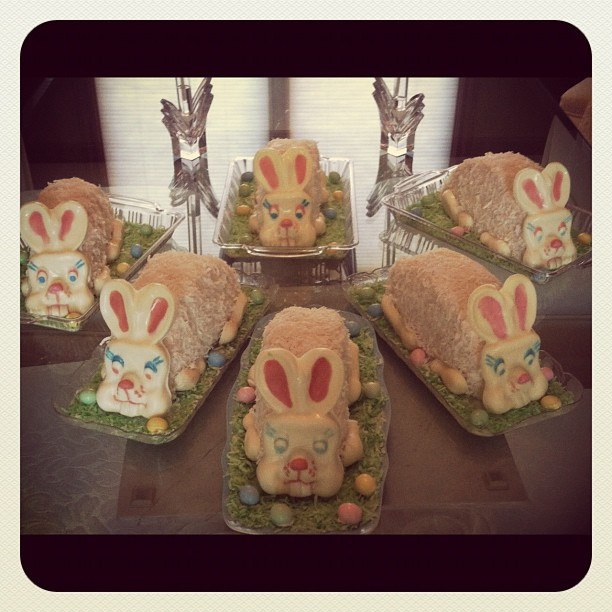Describe the objects in this image and their specific colors. I can see cake in ivory, gray, tan, and brown tones, cake in ivory, gray, tan, and brown tones, cake in ivory, tan, and gray tones, cake in ivory, tan, and gray tones, and cake in ivory, brown, and tan tones in this image. 